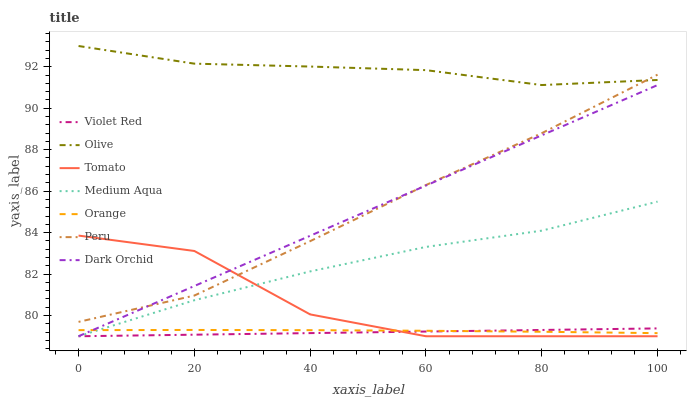Does Violet Red have the minimum area under the curve?
Answer yes or no. Yes. Does Olive have the maximum area under the curve?
Answer yes or no. Yes. Does Dark Orchid have the minimum area under the curve?
Answer yes or no. No. Does Dark Orchid have the maximum area under the curve?
Answer yes or no. No. Is Violet Red the smoothest?
Answer yes or no. Yes. Is Tomato the roughest?
Answer yes or no. Yes. Is Dark Orchid the smoothest?
Answer yes or no. No. Is Dark Orchid the roughest?
Answer yes or no. No. Does Tomato have the lowest value?
Answer yes or no. Yes. Does Orange have the lowest value?
Answer yes or no. No. Does Olive have the highest value?
Answer yes or no. Yes. Does Violet Red have the highest value?
Answer yes or no. No. Is Dark Orchid less than Olive?
Answer yes or no. Yes. Is Olive greater than Orange?
Answer yes or no. Yes. Does Dark Orchid intersect Orange?
Answer yes or no. Yes. Is Dark Orchid less than Orange?
Answer yes or no. No. Is Dark Orchid greater than Orange?
Answer yes or no. No. Does Dark Orchid intersect Olive?
Answer yes or no. No. 